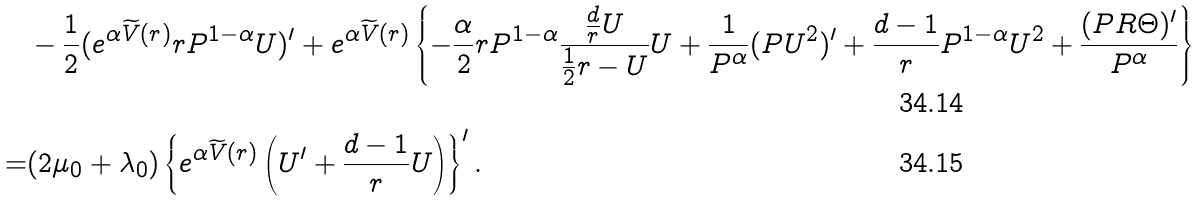<formula> <loc_0><loc_0><loc_500><loc_500>& - \frac { 1 } { 2 } ( e ^ { \alpha \widetilde { V } ( r ) } r P ^ { 1 - \alpha } U ) ^ { \prime } + e ^ { \alpha \widetilde { V } ( r ) } \left \{ - \frac { \alpha } { 2 } r P ^ { 1 - \alpha } \frac { \frac { d } { r } U } { \frac { 1 } { 2 } r - U } U + \frac { 1 } { P ^ { \alpha } } ( P U ^ { 2 } ) ^ { \prime } + \frac { d - 1 } { r } P ^ { 1 - \alpha } U ^ { 2 } + \frac { ( P R \Theta ) ^ { \prime } } { P ^ { \alpha } } \right \} \\ = & ( 2 \mu _ { 0 } + \lambda _ { 0 } ) \left \{ e ^ { \alpha \widetilde { V } ( r ) } \left ( U ^ { \prime } + \frac { d - 1 } { r } U \right ) \right \} ^ { \prime } .</formula> 